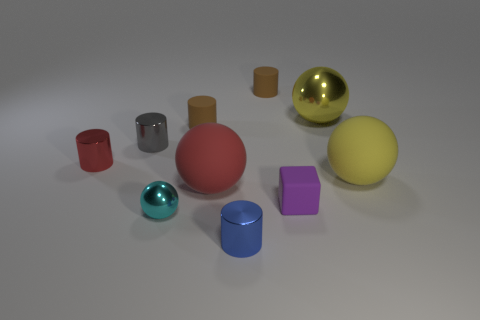Subtract all red spheres. How many spheres are left? 3 Subtract all yellow balls. How many balls are left? 2 Subtract 1 balls. How many balls are left? 3 Subtract all gray balls. Subtract all purple blocks. How many balls are left? 4 Subtract all cyan cubes. How many yellow spheres are left? 2 Subtract all rubber things. Subtract all yellow blocks. How many objects are left? 5 Add 3 red objects. How many red objects are left? 5 Add 6 purple matte blocks. How many purple matte blocks exist? 7 Subtract 0 cyan cylinders. How many objects are left? 10 Subtract all blocks. How many objects are left? 9 